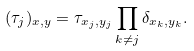<formula> <loc_0><loc_0><loc_500><loc_500>( \tau _ { j } ) _ { x , y } = \tau _ { x _ { j } , y _ { j } } \prod _ { k \ne j } \delta _ { x _ { k } , y _ { k } } .</formula> 